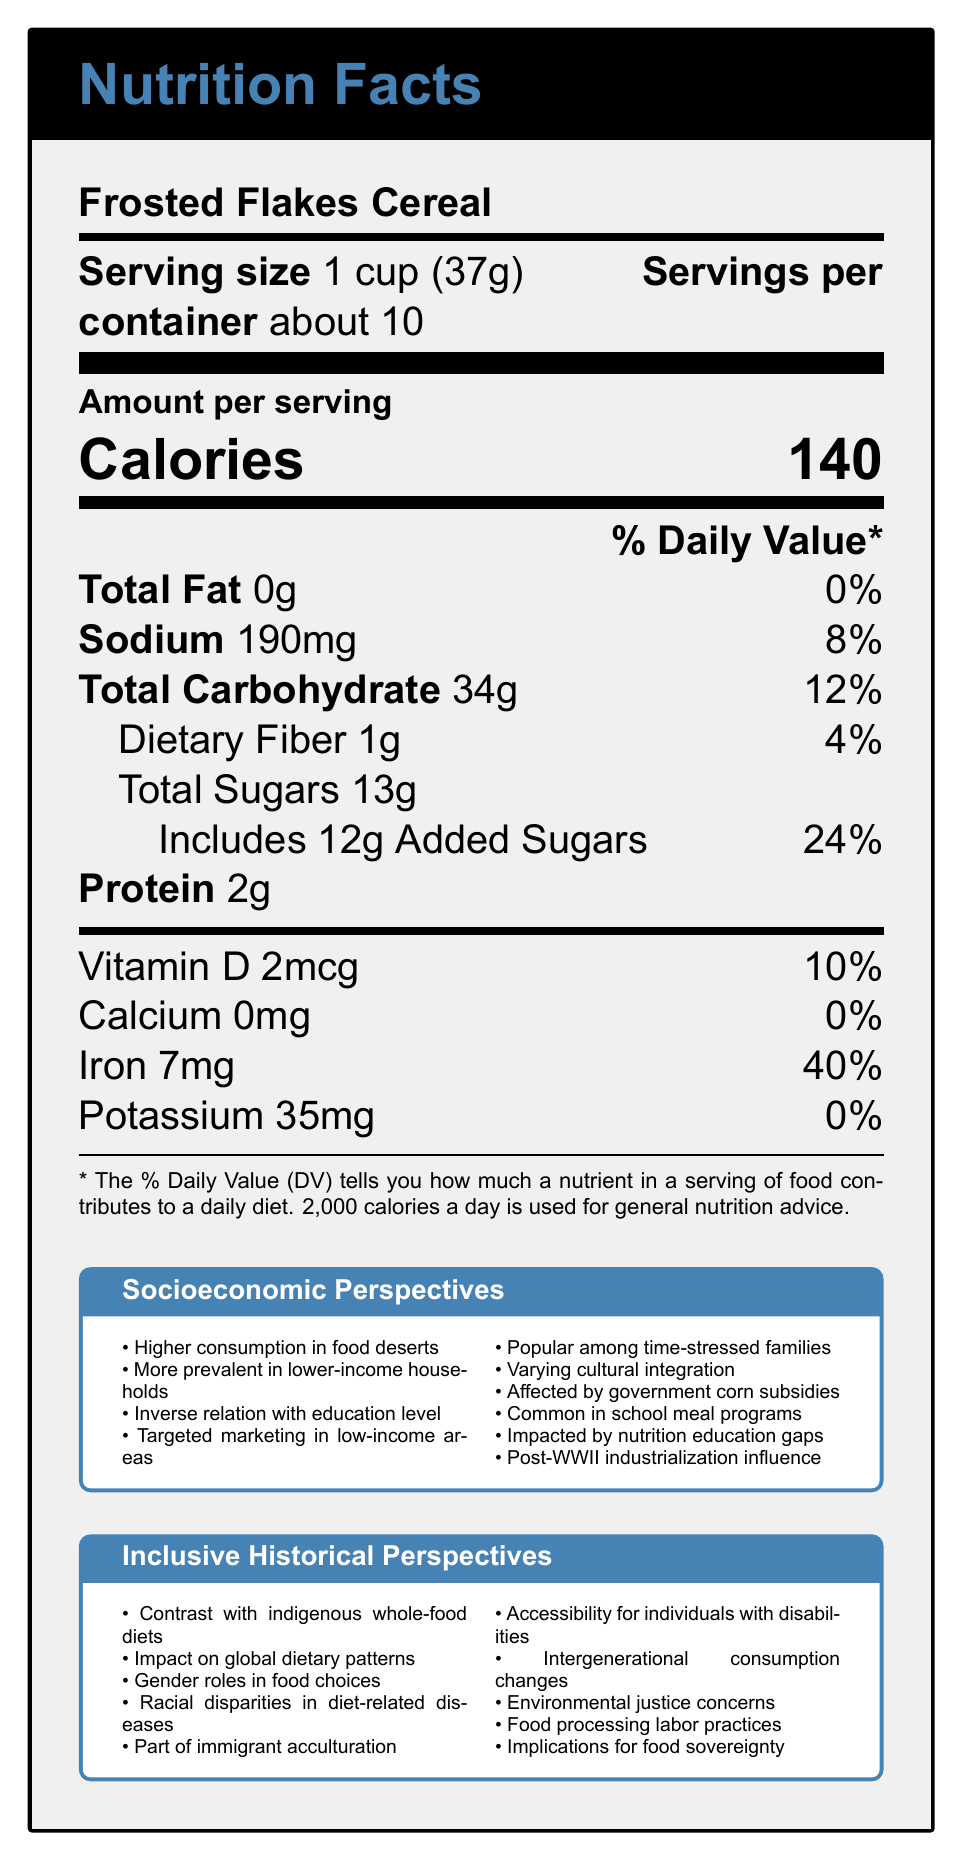what is the serving size of Frosted Flakes Cereal? The serving size is listed at the top of the Nutrition Facts Label as "1 cup (37g)".
Answer: 1 cup (37g) how many calories are in one serving of Frosted Flakes Cereal? The calories per serving are displayed prominently in the middle of the Nutrition Facts Label as "Calories 140".
Answer: 140 how much sodium is in one serving of Frosted Flakes Cereal? The amount of sodium is listed under "Sodium" as "190mg".
Answer: 190mg what is the daily value percentage of iron in one serving of Frosted Flakes Cereal? The daily value percentage of iron is listed next to "Iron" as "40%".
Answer: 40% how many grams of added sugars are in one serving? The amount of added sugars is given under "Includes 12g Added Sugars".
Answer: 12g is calcium present in Frosted Flakes Cereal? Calcium is listed as "0mg," which means there is no calcium present in the cereal.
Answer: No which group sees higher consumption of Frosted Flakes Cereal? A. High-income households B. Low-income households C. Middle-income households The socioeconomic perspectives mention that consumption is "More prevalent in lower-income households due to affordability and longer shelf life."
Answer: B what is the relationship between education level and processed food consumption? A. Positive B. Negative C. Neutral The document states there is an "Inverse relationship between education level and processed food consumption."
Answer: B does gender play a role in food choices according to the document? The inclusive historical perspectives mention "Gender roles in food choices."
Answer: Yes summarize the main idea of the document The document not only includes the usual nutritional facts but also offers a comprehensive overview of socioeconomic and historical contexts related to the consumption of processed foods like Frosted Flakes Cereal.
Answer: The document provides detailed nutritional information for Frosted Flakes Cereal, along with insights into socioeconomic factors and inclusive perspectives affecting its consumption. what drives the higher consumption of processed foods in food deserts? The document notes that there is "Higher consumption in areas with limited access to fresh produce, known as food deserts."
Answer: Limited access to fresh produce what nutrient has the highest daily value percentage in one serving of Frosted Flakes Cereal? The document shows that iron has the highest daily value percentage at 40%.
Answer: Iron does the document provide any information about protein content? The document lists the protein content as "2g" per serving.
Answer: Yes is Frosted Flakes Cereal often included in school meal programs? The socioeconomic factors mention that Frosted Flakes Cereal is "Often included in free or reduced-price school meal programs."
Answer: Yes what is not a listed reason for higher consumption of Frosted Flakes Cereal in certain groups? A. Affordability B. Long shelf life C. High nutrient content The document mentions affordability and longer shelf life but does not mention high nutrient content as a reason.
Answer: C what are government subsidies' role in the consumption of Frosted Flakes Cereal? The document explains that processed cereals like Frosted Flakes benefit from "Indirect subsidies through corn production."
Answer: Indirect subsidies through corn production make processed cereals cheaper what is the amount of dietary fiber in one serving? The nutritional information lists dietary fiber as "1g."
Answer: 1g is there sufficient information to determine the environmental impact of Frosted Flakes Cereal production? The document does not provide specific details on the environmental impact of Frosted Flakes Cereal production.
Answer: Not enough information 